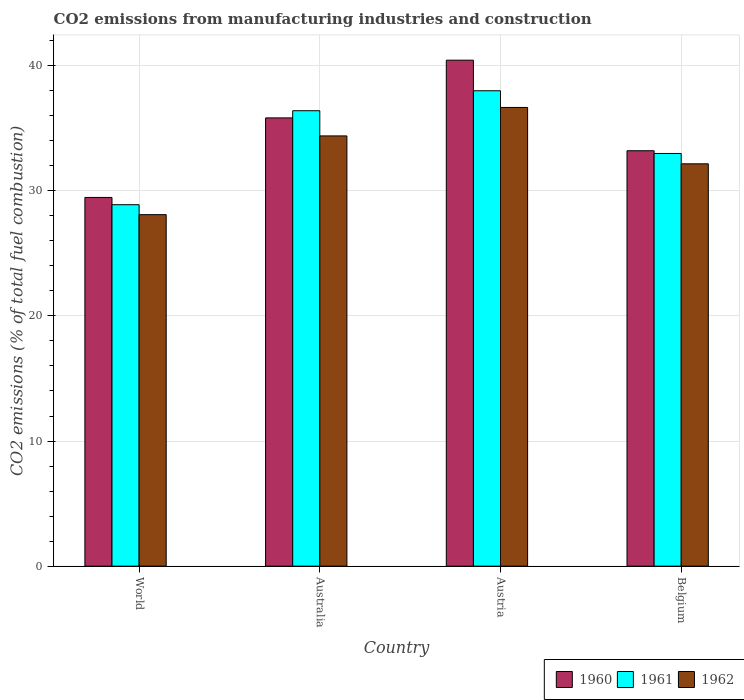How many different coloured bars are there?
Offer a terse response. 3. Are the number of bars on each tick of the X-axis equal?
Your answer should be very brief. Yes. How many bars are there on the 4th tick from the left?
Provide a short and direct response. 3. What is the label of the 1st group of bars from the left?
Your answer should be compact. World. In how many cases, is the number of bars for a given country not equal to the number of legend labels?
Make the answer very short. 0. What is the amount of CO2 emitted in 1960 in Australia?
Ensure brevity in your answer.  35.83. Across all countries, what is the maximum amount of CO2 emitted in 1961?
Offer a very short reply. 37.99. Across all countries, what is the minimum amount of CO2 emitted in 1961?
Provide a succinct answer. 28.89. What is the total amount of CO2 emitted in 1960 in the graph?
Provide a succinct answer. 138.93. What is the difference between the amount of CO2 emitted in 1961 in Australia and that in World?
Keep it short and to the point. 7.51. What is the difference between the amount of CO2 emitted in 1962 in World and the amount of CO2 emitted in 1960 in Austria?
Your answer should be compact. -12.35. What is the average amount of CO2 emitted in 1960 per country?
Your answer should be compact. 34.73. What is the difference between the amount of CO2 emitted of/in 1962 and amount of CO2 emitted of/in 1961 in Australia?
Ensure brevity in your answer.  -2.01. In how many countries, is the amount of CO2 emitted in 1960 greater than 14 %?
Your response must be concise. 4. What is the ratio of the amount of CO2 emitted in 1960 in Australia to that in Belgium?
Provide a succinct answer. 1.08. Is the amount of CO2 emitted in 1962 in Austria less than that in Belgium?
Provide a short and direct response. No. What is the difference between the highest and the second highest amount of CO2 emitted in 1961?
Your answer should be compact. -3.42. What is the difference between the highest and the lowest amount of CO2 emitted in 1960?
Provide a succinct answer. 10.97. Is the sum of the amount of CO2 emitted in 1962 in Australia and World greater than the maximum amount of CO2 emitted in 1960 across all countries?
Provide a succinct answer. Yes. Are all the bars in the graph horizontal?
Your response must be concise. No. What is the difference between two consecutive major ticks on the Y-axis?
Ensure brevity in your answer.  10. Does the graph contain grids?
Offer a very short reply. Yes. Where does the legend appear in the graph?
Provide a succinct answer. Bottom right. How many legend labels are there?
Make the answer very short. 3. What is the title of the graph?
Your response must be concise. CO2 emissions from manufacturing industries and construction. What is the label or title of the Y-axis?
Make the answer very short. CO2 emissions (% of total fuel combustion). What is the CO2 emissions (% of total fuel combustion) of 1960 in World?
Make the answer very short. 29.47. What is the CO2 emissions (% of total fuel combustion) of 1961 in World?
Your answer should be very brief. 28.89. What is the CO2 emissions (% of total fuel combustion) in 1962 in World?
Keep it short and to the point. 28.09. What is the CO2 emissions (% of total fuel combustion) in 1960 in Australia?
Keep it short and to the point. 35.83. What is the CO2 emissions (% of total fuel combustion) in 1961 in Australia?
Provide a short and direct response. 36.4. What is the CO2 emissions (% of total fuel combustion) of 1962 in Australia?
Provide a short and direct response. 34.39. What is the CO2 emissions (% of total fuel combustion) of 1960 in Austria?
Offer a very short reply. 40.44. What is the CO2 emissions (% of total fuel combustion) of 1961 in Austria?
Your response must be concise. 37.99. What is the CO2 emissions (% of total fuel combustion) in 1962 in Austria?
Provide a short and direct response. 36.66. What is the CO2 emissions (% of total fuel combustion) of 1960 in Belgium?
Provide a succinct answer. 33.2. What is the CO2 emissions (% of total fuel combustion) in 1961 in Belgium?
Ensure brevity in your answer.  32.98. What is the CO2 emissions (% of total fuel combustion) in 1962 in Belgium?
Your response must be concise. 32.16. Across all countries, what is the maximum CO2 emissions (% of total fuel combustion) of 1960?
Your answer should be very brief. 40.44. Across all countries, what is the maximum CO2 emissions (% of total fuel combustion) of 1961?
Provide a short and direct response. 37.99. Across all countries, what is the maximum CO2 emissions (% of total fuel combustion) in 1962?
Provide a short and direct response. 36.66. Across all countries, what is the minimum CO2 emissions (% of total fuel combustion) in 1960?
Provide a succinct answer. 29.47. Across all countries, what is the minimum CO2 emissions (% of total fuel combustion) in 1961?
Ensure brevity in your answer.  28.89. Across all countries, what is the minimum CO2 emissions (% of total fuel combustion) in 1962?
Provide a succinct answer. 28.09. What is the total CO2 emissions (% of total fuel combustion) in 1960 in the graph?
Keep it short and to the point. 138.93. What is the total CO2 emissions (% of total fuel combustion) of 1961 in the graph?
Provide a succinct answer. 136.27. What is the total CO2 emissions (% of total fuel combustion) in 1962 in the graph?
Keep it short and to the point. 131.3. What is the difference between the CO2 emissions (% of total fuel combustion) in 1960 in World and that in Australia?
Your answer should be very brief. -6.36. What is the difference between the CO2 emissions (% of total fuel combustion) of 1961 in World and that in Australia?
Provide a short and direct response. -7.51. What is the difference between the CO2 emissions (% of total fuel combustion) of 1962 in World and that in Australia?
Ensure brevity in your answer.  -6.29. What is the difference between the CO2 emissions (% of total fuel combustion) of 1960 in World and that in Austria?
Offer a terse response. -10.97. What is the difference between the CO2 emissions (% of total fuel combustion) of 1961 in World and that in Austria?
Your answer should be compact. -9.11. What is the difference between the CO2 emissions (% of total fuel combustion) in 1962 in World and that in Austria?
Provide a short and direct response. -8.57. What is the difference between the CO2 emissions (% of total fuel combustion) of 1960 in World and that in Belgium?
Offer a very short reply. -3.73. What is the difference between the CO2 emissions (% of total fuel combustion) in 1961 in World and that in Belgium?
Offer a terse response. -4.09. What is the difference between the CO2 emissions (% of total fuel combustion) in 1962 in World and that in Belgium?
Give a very brief answer. -4.06. What is the difference between the CO2 emissions (% of total fuel combustion) of 1960 in Australia and that in Austria?
Keep it short and to the point. -4.61. What is the difference between the CO2 emissions (% of total fuel combustion) of 1961 in Australia and that in Austria?
Offer a very short reply. -1.6. What is the difference between the CO2 emissions (% of total fuel combustion) of 1962 in Australia and that in Austria?
Keep it short and to the point. -2.28. What is the difference between the CO2 emissions (% of total fuel combustion) in 1960 in Australia and that in Belgium?
Your answer should be compact. 2.63. What is the difference between the CO2 emissions (% of total fuel combustion) of 1961 in Australia and that in Belgium?
Make the answer very short. 3.42. What is the difference between the CO2 emissions (% of total fuel combustion) in 1962 in Australia and that in Belgium?
Your answer should be very brief. 2.23. What is the difference between the CO2 emissions (% of total fuel combustion) in 1960 in Austria and that in Belgium?
Your response must be concise. 7.24. What is the difference between the CO2 emissions (% of total fuel combustion) of 1961 in Austria and that in Belgium?
Provide a succinct answer. 5.01. What is the difference between the CO2 emissions (% of total fuel combustion) in 1962 in Austria and that in Belgium?
Offer a very short reply. 4.51. What is the difference between the CO2 emissions (% of total fuel combustion) of 1960 in World and the CO2 emissions (% of total fuel combustion) of 1961 in Australia?
Ensure brevity in your answer.  -6.93. What is the difference between the CO2 emissions (% of total fuel combustion) of 1960 in World and the CO2 emissions (% of total fuel combustion) of 1962 in Australia?
Your answer should be compact. -4.92. What is the difference between the CO2 emissions (% of total fuel combustion) in 1961 in World and the CO2 emissions (% of total fuel combustion) in 1962 in Australia?
Make the answer very short. -5.5. What is the difference between the CO2 emissions (% of total fuel combustion) of 1960 in World and the CO2 emissions (% of total fuel combustion) of 1961 in Austria?
Keep it short and to the point. -8.53. What is the difference between the CO2 emissions (% of total fuel combustion) in 1960 in World and the CO2 emissions (% of total fuel combustion) in 1962 in Austria?
Give a very brief answer. -7.19. What is the difference between the CO2 emissions (% of total fuel combustion) of 1961 in World and the CO2 emissions (% of total fuel combustion) of 1962 in Austria?
Offer a very short reply. -7.77. What is the difference between the CO2 emissions (% of total fuel combustion) of 1960 in World and the CO2 emissions (% of total fuel combustion) of 1961 in Belgium?
Ensure brevity in your answer.  -3.51. What is the difference between the CO2 emissions (% of total fuel combustion) in 1960 in World and the CO2 emissions (% of total fuel combustion) in 1962 in Belgium?
Offer a very short reply. -2.69. What is the difference between the CO2 emissions (% of total fuel combustion) of 1961 in World and the CO2 emissions (% of total fuel combustion) of 1962 in Belgium?
Ensure brevity in your answer.  -3.27. What is the difference between the CO2 emissions (% of total fuel combustion) in 1960 in Australia and the CO2 emissions (% of total fuel combustion) in 1961 in Austria?
Make the answer very short. -2.17. What is the difference between the CO2 emissions (% of total fuel combustion) of 1960 in Australia and the CO2 emissions (% of total fuel combustion) of 1962 in Austria?
Offer a terse response. -0.84. What is the difference between the CO2 emissions (% of total fuel combustion) of 1961 in Australia and the CO2 emissions (% of total fuel combustion) of 1962 in Austria?
Give a very brief answer. -0.26. What is the difference between the CO2 emissions (% of total fuel combustion) in 1960 in Australia and the CO2 emissions (% of total fuel combustion) in 1961 in Belgium?
Offer a very short reply. 2.84. What is the difference between the CO2 emissions (% of total fuel combustion) of 1960 in Australia and the CO2 emissions (% of total fuel combustion) of 1962 in Belgium?
Provide a short and direct response. 3.67. What is the difference between the CO2 emissions (% of total fuel combustion) of 1961 in Australia and the CO2 emissions (% of total fuel combustion) of 1962 in Belgium?
Give a very brief answer. 4.24. What is the difference between the CO2 emissions (% of total fuel combustion) in 1960 in Austria and the CO2 emissions (% of total fuel combustion) in 1961 in Belgium?
Provide a succinct answer. 7.46. What is the difference between the CO2 emissions (% of total fuel combustion) in 1960 in Austria and the CO2 emissions (% of total fuel combustion) in 1962 in Belgium?
Your response must be concise. 8.28. What is the difference between the CO2 emissions (% of total fuel combustion) in 1961 in Austria and the CO2 emissions (% of total fuel combustion) in 1962 in Belgium?
Offer a terse response. 5.84. What is the average CO2 emissions (% of total fuel combustion) of 1960 per country?
Offer a terse response. 34.73. What is the average CO2 emissions (% of total fuel combustion) of 1961 per country?
Offer a terse response. 34.07. What is the average CO2 emissions (% of total fuel combustion) of 1962 per country?
Make the answer very short. 32.82. What is the difference between the CO2 emissions (% of total fuel combustion) in 1960 and CO2 emissions (% of total fuel combustion) in 1961 in World?
Offer a terse response. 0.58. What is the difference between the CO2 emissions (% of total fuel combustion) of 1960 and CO2 emissions (% of total fuel combustion) of 1962 in World?
Your answer should be compact. 1.38. What is the difference between the CO2 emissions (% of total fuel combustion) of 1961 and CO2 emissions (% of total fuel combustion) of 1962 in World?
Ensure brevity in your answer.  0.79. What is the difference between the CO2 emissions (% of total fuel combustion) in 1960 and CO2 emissions (% of total fuel combustion) in 1961 in Australia?
Offer a very short reply. -0.57. What is the difference between the CO2 emissions (% of total fuel combustion) in 1960 and CO2 emissions (% of total fuel combustion) in 1962 in Australia?
Your response must be concise. 1.44. What is the difference between the CO2 emissions (% of total fuel combustion) in 1961 and CO2 emissions (% of total fuel combustion) in 1962 in Australia?
Keep it short and to the point. 2.01. What is the difference between the CO2 emissions (% of total fuel combustion) of 1960 and CO2 emissions (% of total fuel combustion) of 1961 in Austria?
Ensure brevity in your answer.  2.44. What is the difference between the CO2 emissions (% of total fuel combustion) in 1960 and CO2 emissions (% of total fuel combustion) in 1962 in Austria?
Ensure brevity in your answer.  3.78. What is the difference between the CO2 emissions (% of total fuel combustion) in 1961 and CO2 emissions (% of total fuel combustion) in 1962 in Austria?
Offer a terse response. 1.33. What is the difference between the CO2 emissions (% of total fuel combustion) of 1960 and CO2 emissions (% of total fuel combustion) of 1961 in Belgium?
Provide a succinct answer. 0.22. What is the difference between the CO2 emissions (% of total fuel combustion) in 1960 and CO2 emissions (% of total fuel combustion) in 1962 in Belgium?
Offer a terse response. 1.04. What is the difference between the CO2 emissions (% of total fuel combustion) of 1961 and CO2 emissions (% of total fuel combustion) of 1962 in Belgium?
Provide a short and direct response. 0.83. What is the ratio of the CO2 emissions (% of total fuel combustion) of 1960 in World to that in Australia?
Your answer should be compact. 0.82. What is the ratio of the CO2 emissions (% of total fuel combustion) of 1961 in World to that in Australia?
Your answer should be very brief. 0.79. What is the ratio of the CO2 emissions (% of total fuel combustion) of 1962 in World to that in Australia?
Your answer should be very brief. 0.82. What is the ratio of the CO2 emissions (% of total fuel combustion) of 1960 in World to that in Austria?
Ensure brevity in your answer.  0.73. What is the ratio of the CO2 emissions (% of total fuel combustion) in 1961 in World to that in Austria?
Ensure brevity in your answer.  0.76. What is the ratio of the CO2 emissions (% of total fuel combustion) of 1962 in World to that in Austria?
Offer a very short reply. 0.77. What is the ratio of the CO2 emissions (% of total fuel combustion) in 1960 in World to that in Belgium?
Make the answer very short. 0.89. What is the ratio of the CO2 emissions (% of total fuel combustion) in 1961 in World to that in Belgium?
Your answer should be compact. 0.88. What is the ratio of the CO2 emissions (% of total fuel combustion) of 1962 in World to that in Belgium?
Give a very brief answer. 0.87. What is the ratio of the CO2 emissions (% of total fuel combustion) in 1960 in Australia to that in Austria?
Your answer should be compact. 0.89. What is the ratio of the CO2 emissions (% of total fuel combustion) of 1961 in Australia to that in Austria?
Your response must be concise. 0.96. What is the ratio of the CO2 emissions (% of total fuel combustion) in 1962 in Australia to that in Austria?
Your answer should be very brief. 0.94. What is the ratio of the CO2 emissions (% of total fuel combustion) of 1960 in Australia to that in Belgium?
Your answer should be very brief. 1.08. What is the ratio of the CO2 emissions (% of total fuel combustion) in 1961 in Australia to that in Belgium?
Your answer should be very brief. 1.1. What is the ratio of the CO2 emissions (% of total fuel combustion) of 1962 in Australia to that in Belgium?
Your response must be concise. 1.07. What is the ratio of the CO2 emissions (% of total fuel combustion) of 1960 in Austria to that in Belgium?
Ensure brevity in your answer.  1.22. What is the ratio of the CO2 emissions (% of total fuel combustion) of 1961 in Austria to that in Belgium?
Make the answer very short. 1.15. What is the ratio of the CO2 emissions (% of total fuel combustion) in 1962 in Austria to that in Belgium?
Ensure brevity in your answer.  1.14. What is the difference between the highest and the second highest CO2 emissions (% of total fuel combustion) in 1960?
Your response must be concise. 4.61. What is the difference between the highest and the second highest CO2 emissions (% of total fuel combustion) of 1961?
Your answer should be very brief. 1.6. What is the difference between the highest and the second highest CO2 emissions (% of total fuel combustion) of 1962?
Your answer should be compact. 2.28. What is the difference between the highest and the lowest CO2 emissions (% of total fuel combustion) of 1960?
Make the answer very short. 10.97. What is the difference between the highest and the lowest CO2 emissions (% of total fuel combustion) in 1961?
Your answer should be very brief. 9.11. What is the difference between the highest and the lowest CO2 emissions (% of total fuel combustion) of 1962?
Give a very brief answer. 8.57. 